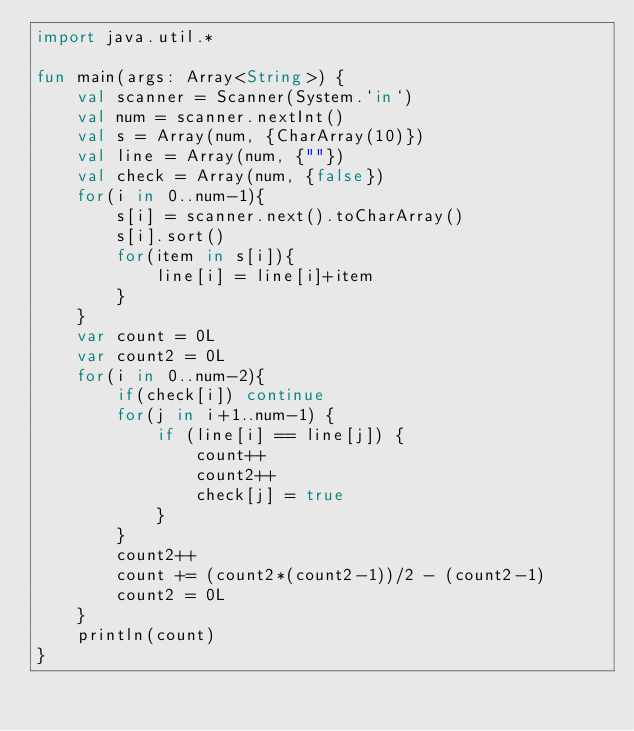<code> <loc_0><loc_0><loc_500><loc_500><_Kotlin_>import java.util.*

fun main(args: Array<String>) {
    val scanner = Scanner(System.`in`)
    val num = scanner.nextInt()
    val s = Array(num, {CharArray(10)})
    val line = Array(num, {""})
    val check = Array(num, {false})
    for(i in 0..num-1){
        s[i] = scanner.next().toCharArray()
        s[i].sort()
        for(item in s[i]){
            line[i] = line[i]+item
        }
    }
    var count = 0L
    var count2 = 0L
    for(i in 0..num-2){
        if(check[i]) continue
        for(j in i+1..num-1) {
            if (line[i] == line[j]) {
                count++
                count2++
                check[j] = true
            }
        }
        count2++
        count += (count2*(count2-1))/2 - (count2-1)
        count2 = 0L
    }
    println(count)
}</code> 